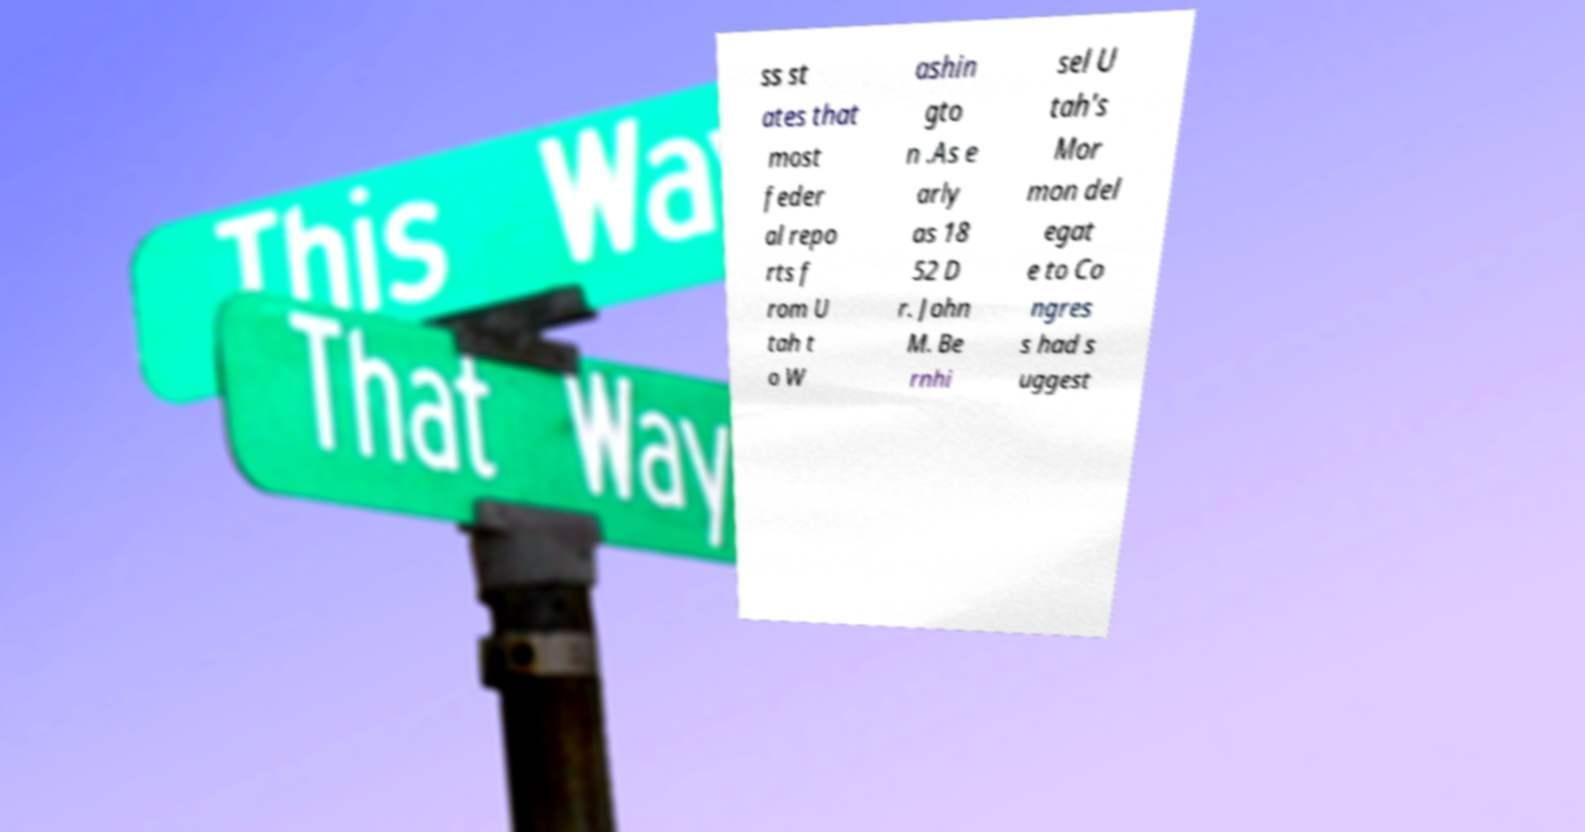For documentation purposes, I need the text within this image transcribed. Could you provide that? ss st ates that most feder al repo rts f rom U tah t o W ashin gto n .As e arly as 18 52 D r. John M. Be rnhi sel U tah's Mor mon del egat e to Co ngres s had s uggest 